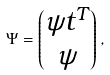<formula> <loc_0><loc_0><loc_500><loc_500>\Psi = \begin{pmatrix} \psi t ^ { T } \\ \psi \end{pmatrix} ,</formula> 